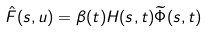Convert formula to latex. <formula><loc_0><loc_0><loc_500><loc_500>\hat { F } ( s , u ) = \beta ( t ) H ( s , t ) \widetilde { \Phi } ( s , t )</formula> 